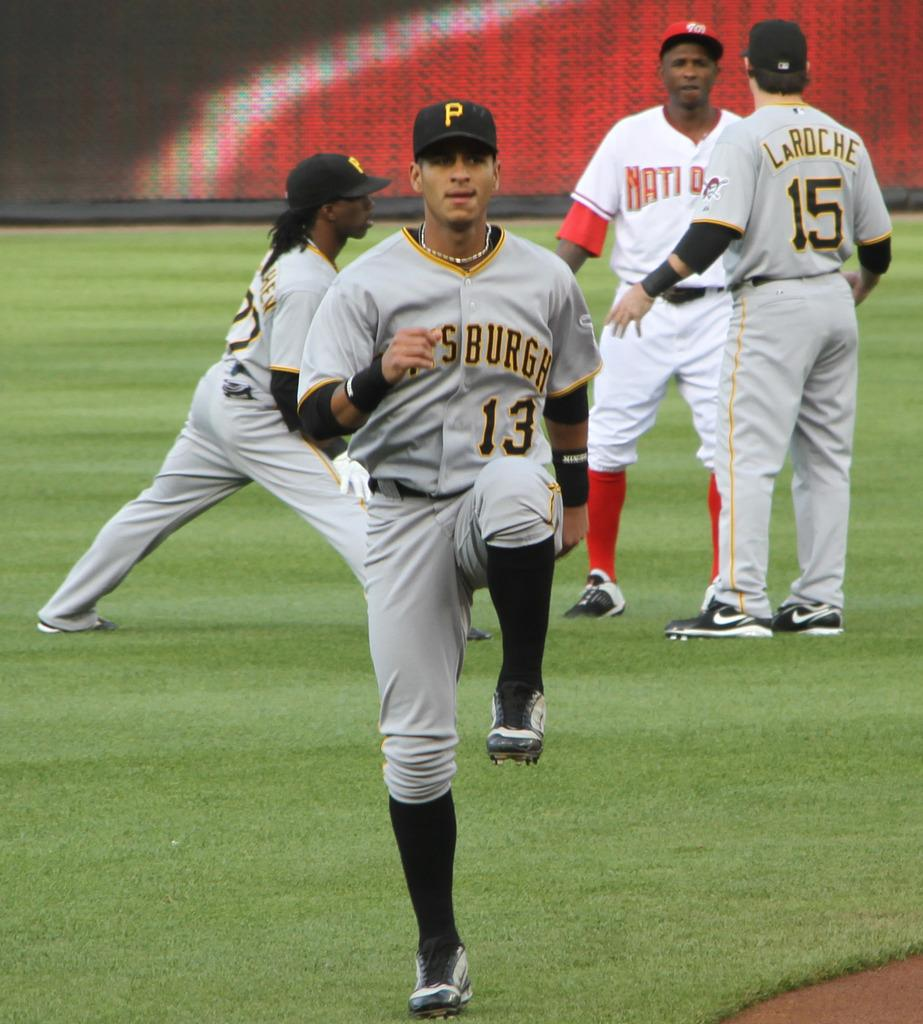Provide a one-sentence caption for the provided image. some baseball players on the field warming up and talking, one of the teams is Pittsburgh with two of their jerseys saying numbers 15 and 13. 